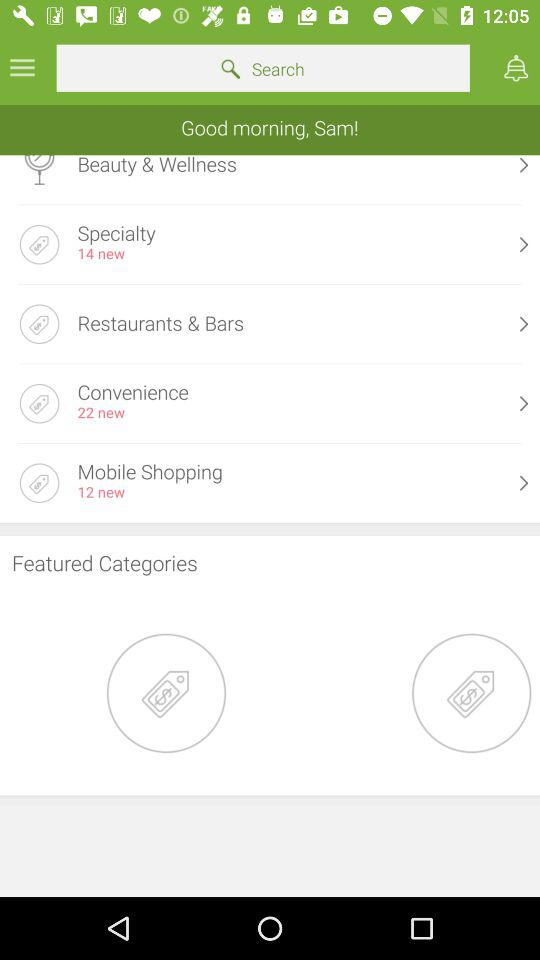What is the user name? The user name is Sam. 